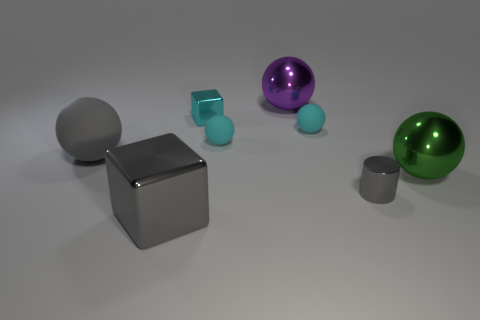There is a matte object that is both on the right side of the small cyan metal block and left of the big purple metal thing; what shape is it?
Keep it short and to the point. Sphere. What number of tiny objects are either green cylinders or gray metal blocks?
Provide a succinct answer. 0. What is the tiny cylinder made of?
Give a very brief answer. Metal. What number of other objects are the same shape as the gray matte thing?
Keep it short and to the point. 4. What is the size of the cyan metal thing?
Give a very brief answer. Small. What is the size of the gray object that is both behind the gray block and to the left of the small cylinder?
Offer a terse response. Large. The large metal thing that is in front of the green sphere has what shape?
Your answer should be compact. Cube. Is the material of the large green ball the same as the big purple ball on the right side of the large rubber object?
Ensure brevity in your answer.  Yes. Is the gray rubber object the same shape as the green shiny thing?
Your response must be concise. Yes. What is the material of the large gray thing that is the same shape as the green shiny thing?
Provide a succinct answer. Rubber. 